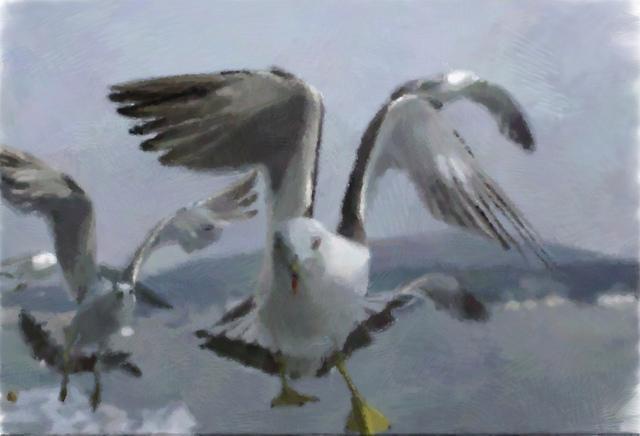How many birds are there?
Give a very brief answer. 2. 